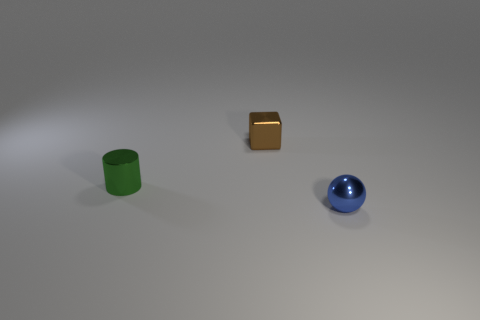Are there any tiny blue metal spheres that are in front of the tiny object that is to the left of the small metal object that is behind the green object?
Your response must be concise. Yes. What number of small metal blocks are there?
Offer a terse response. 1. How many objects are either metal things to the right of the cylinder or small things that are behind the sphere?
Keep it short and to the point. 3. Does the thing behind the shiny cylinder have the same size as the tiny cylinder?
Give a very brief answer. Yes. There is a brown object that is the same size as the blue shiny ball; what is its material?
Offer a very short reply. Metal. How many other things are there of the same size as the brown block?
Provide a succinct answer. 2. What is the shape of the brown metallic thing?
Make the answer very short. Cube. There is a shiny object that is both in front of the brown metal thing and behind the small blue metal object; what color is it?
Provide a succinct answer. Green. What is the small brown block made of?
Provide a succinct answer. Metal. There is a small object that is in front of the green cylinder; what shape is it?
Offer a very short reply. Sphere. 